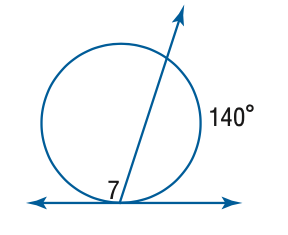Answer the mathemtical geometry problem and directly provide the correct option letter.
Question: Find the measure of \angle 7.
Choices: A: 70 B: 110 C: 140 D: 220 B 